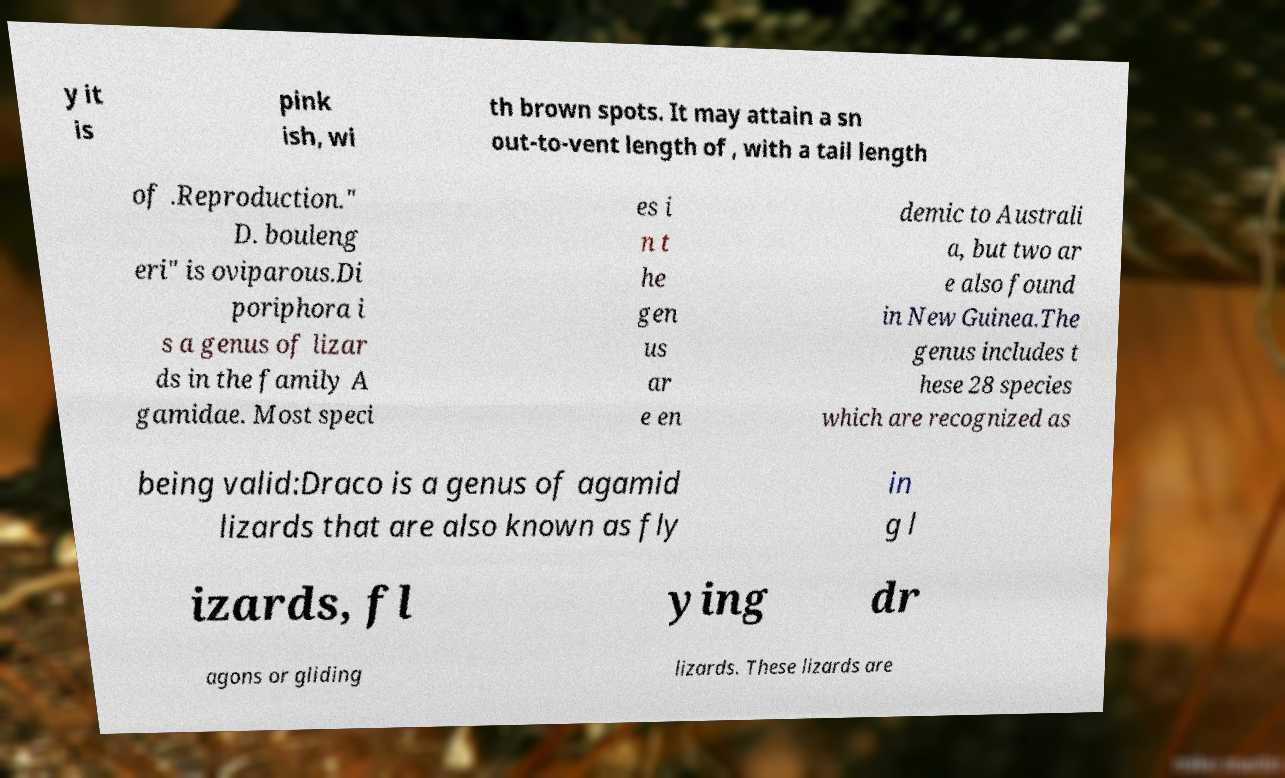For documentation purposes, I need the text within this image transcribed. Could you provide that? y it is pink ish, wi th brown spots. It may attain a sn out-to-vent length of , with a tail length of .Reproduction." D. bouleng eri" is oviparous.Di poriphora i s a genus of lizar ds in the family A gamidae. Most speci es i n t he gen us ar e en demic to Australi a, but two ar e also found in New Guinea.The genus includes t hese 28 species which are recognized as being valid:Draco is a genus of agamid lizards that are also known as fly in g l izards, fl ying dr agons or gliding lizards. These lizards are 